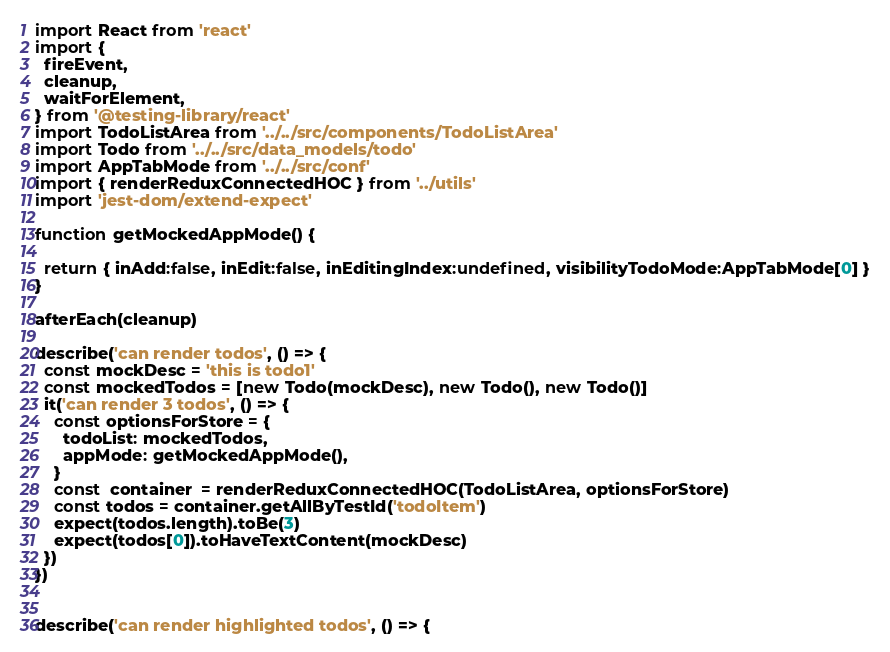<code> <loc_0><loc_0><loc_500><loc_500><_JavaScript_>import React from 'react'
import {
  fireEvent,
  cleanup,
  waitForElement,
} from '@testing-library/react'
import TodoListArea from '../../src/components/TodoListArea'
import Todo from '../../src/data_models/todo'
import AppTabMode from '../../src/conf' 
import { renderReduxConnectedHOC } from '../utils'
import 'jest-dom/extend-expect'

function getMockedAppMode() {

  return { inAdd:false, inEdit:false, inEditingIndex:undefined, visibilityTodoMode:AppTabMode[0] }
}

afterEach(cleanup)

describe('can render todos', () => {
  const mockDesc = 'this is todo1'
  const mockedTodos = [new Todo(mockDesc), new Todo(), new Todo()]
  it('can render 3 todos', () => {
    const optionsForStore = {
      todoList: mockedTodos, 
      appMode: getMockedAppMode(),
    }
    const  container  = renderReduxConnectedHOC(TodoListArea, optionsForStore)
    const todos = container.getAllByTestId('todoItem')
    expect(todos.length).toBe(3)
    expect(todos[0]).toHaveTextContent(mockDesc)
  })
})


describe('can render highlighted todos', () => {</code> 